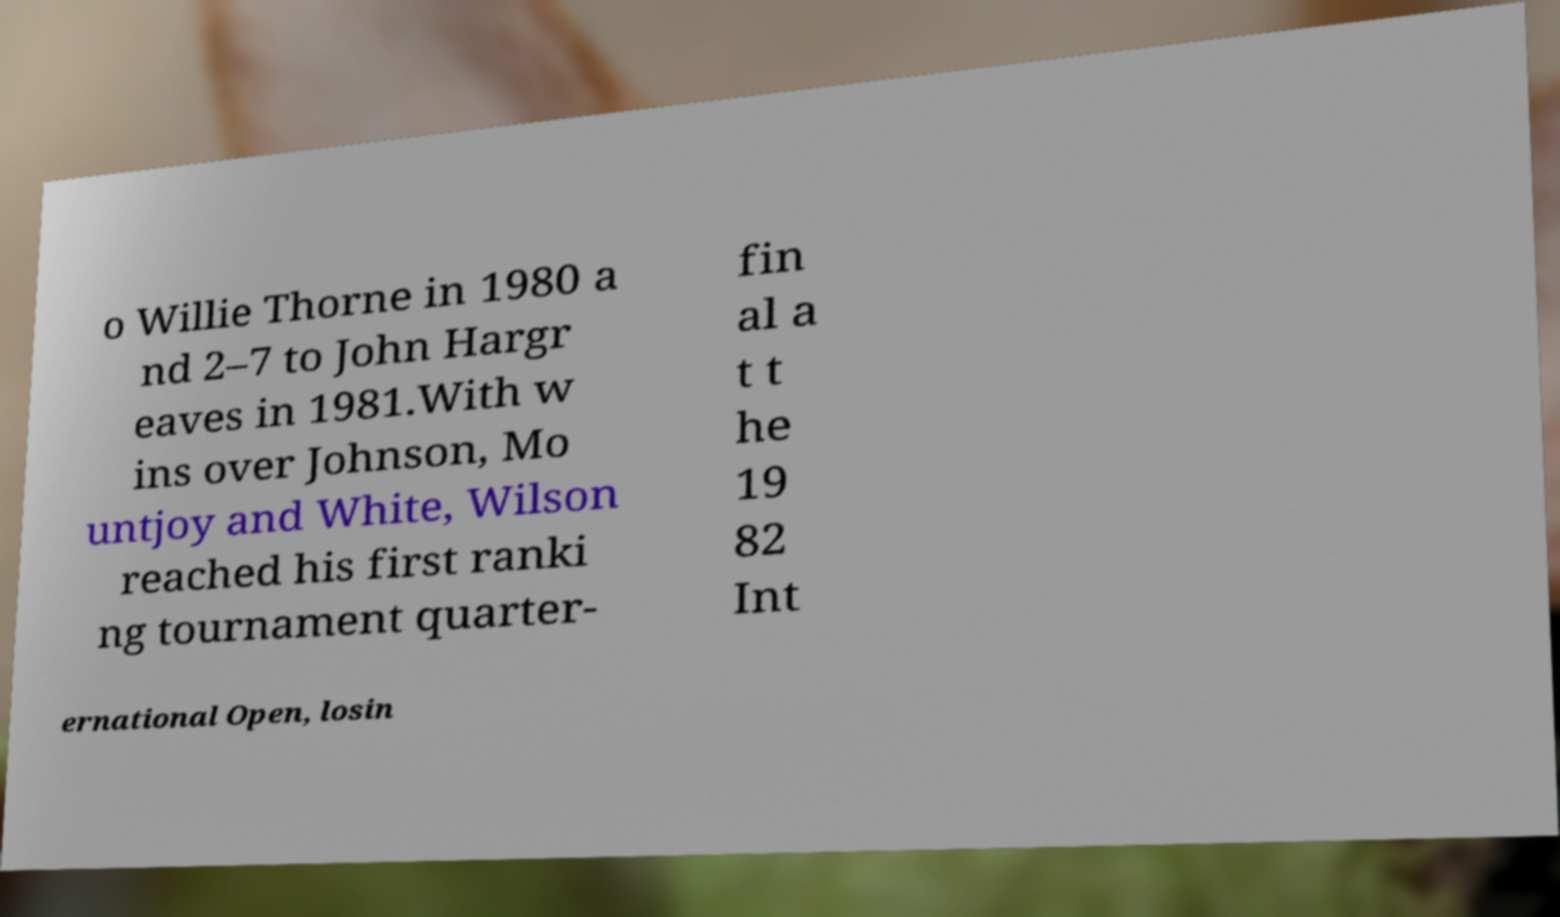Could you assist in decoding the text presented in this image and type it out clearly? o Willie Thorne in 1980 a nd 2–7 to John Hargr eaves in 1981.With w ins over Johnson, Mo untjoy and White, Wilson reached his first ranki ng tournament quarter- fin al a t t he 19 82 Int ernational Open, losin 